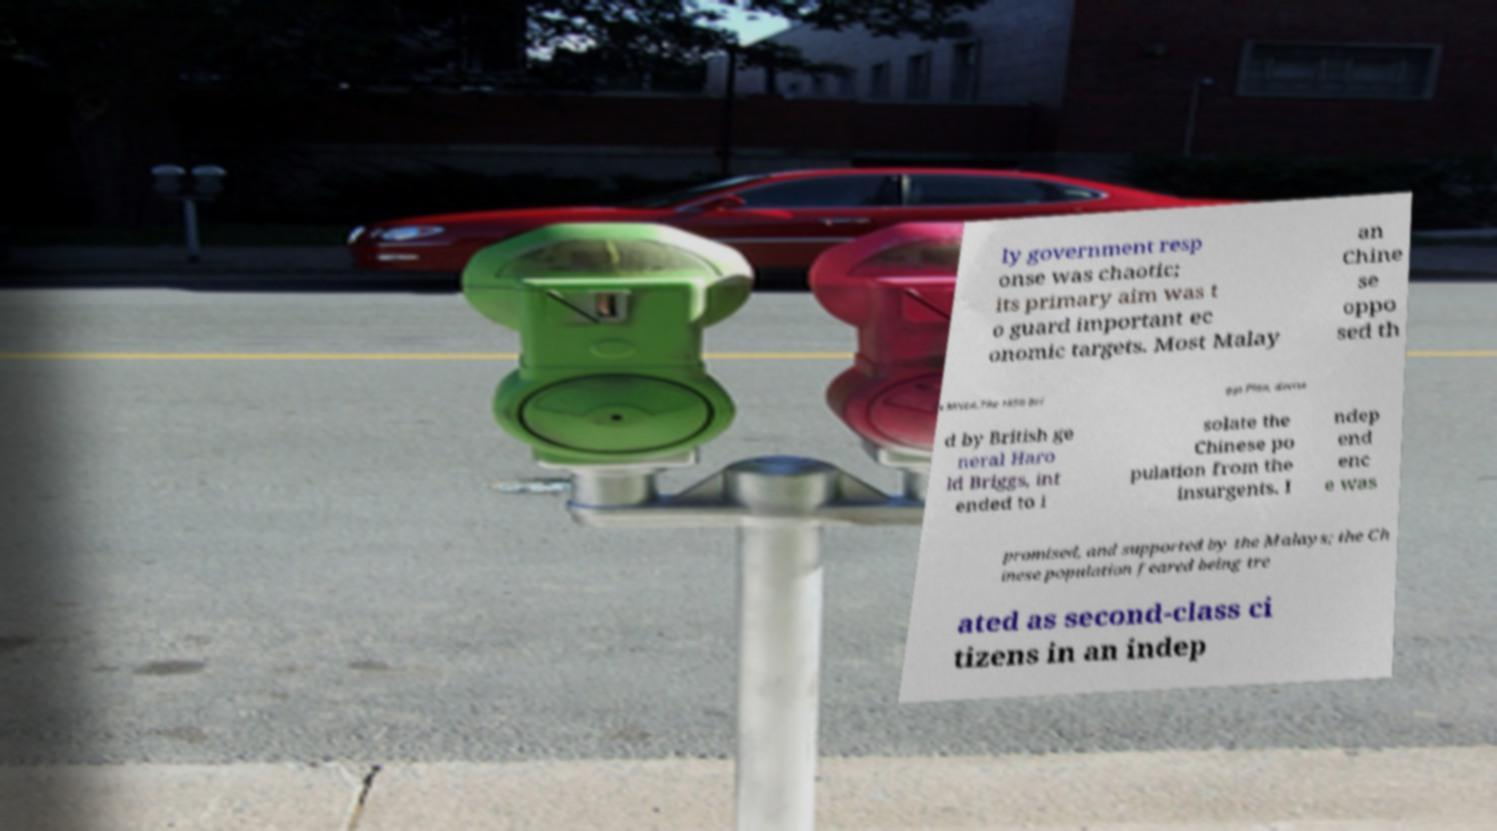What messages or text are displayed in this image? I need them in a readable, typed format. ly government resp onse was chaotic; its primary aim was t o guard important ec onomic targets. Most Malay an Chine se oppo sed th e MNLA.The 1950 Bri ggs Plan, devise d by British ge neral Haro ld Briggs, int ended to i solate the Chinese po pulation from the insurgents. I ndep end enc e was promised, and supported by the Malays; the Ch inese population feared being tre ated as second-class ci tizens in an indep 